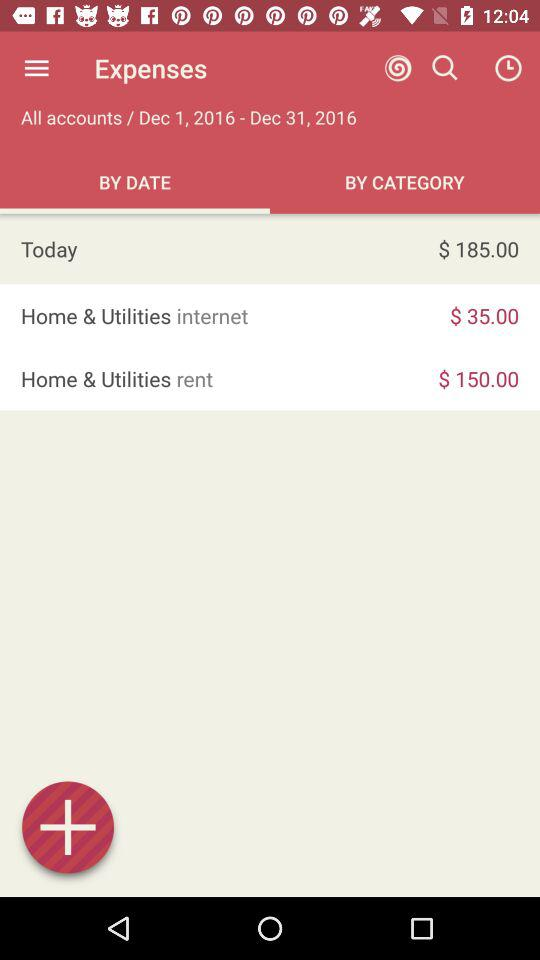How much more is the rent than the internet bill?
Answer the question using a single word or phrase. $115.00 